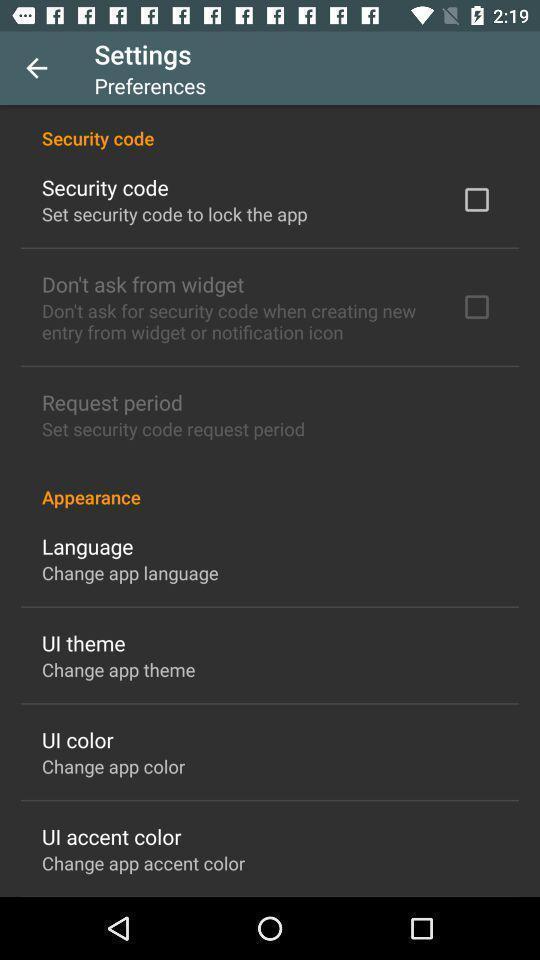Give me a narrative description of this picture. Settings page with different appearances in the app. 